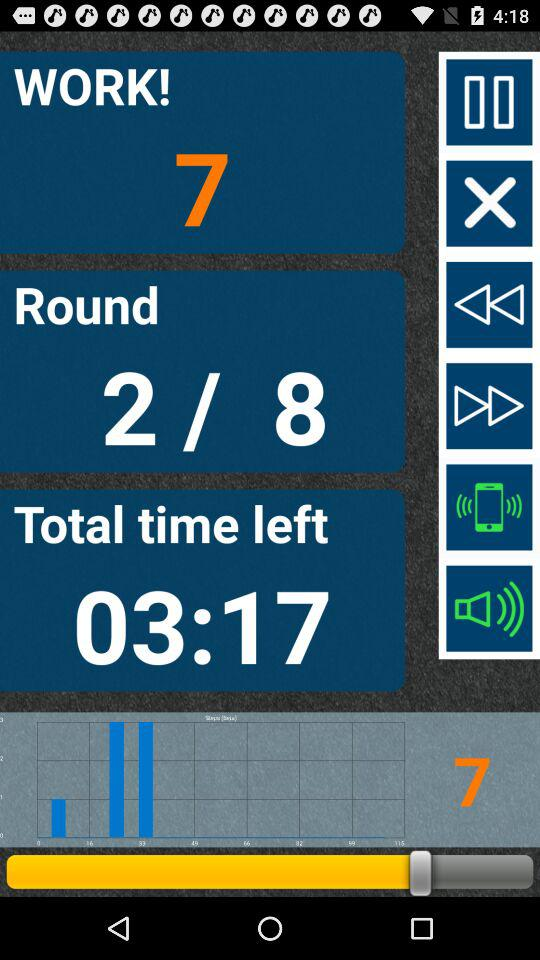Which round are we at? You are at round 2. 